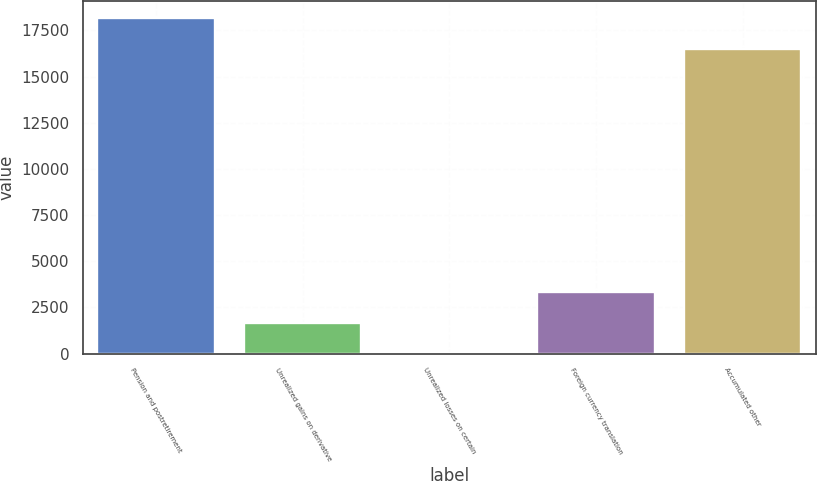Convert chart. <chart><loc_0><loc_0><loc_500><loc_500><bar_chart><fcel>Pension and postretirement<fcel>Unrealized gains on derivative<fcel>Unrealized losses on certain<fcel>Foreign currency translation<fcel>Accumulated other<nl><fcel>18174.7<fcel>1682.7<fcel>8<fcel>3357.4<fcel>16500<nl></chart> 